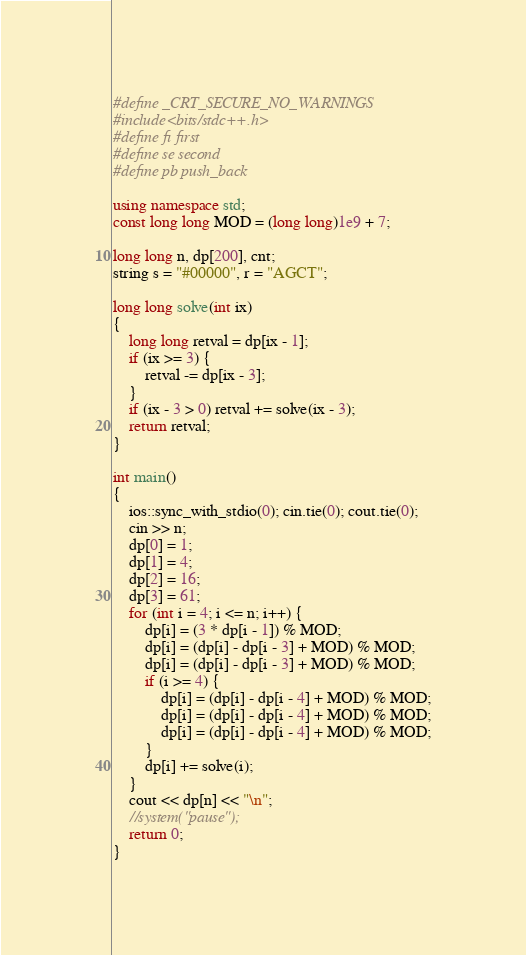Convert code to text. <code><loc_0><loc_0><loc_500><loc_500><_C++_>#define _CRT_SECURE_NO_WARNINGS
#include<bits/stdc++.h>
#define fi first
#define se second
#define pb push_back

using namespace std;
const long long MOD = (long long)1e9 + 7;

long long n, dp[200], cnt;
string s = "#00000", r = "AGCT";

long long solve(int ix)
{
	long long retval = dp[ix - 1];
	if (ix >= 3) {
		retval -= dp[ix - 3];
	}
	if (ix - 3 > 0) retval += solve(ix - 3);
	return retval;
}

int main()
{
	ios::sync_with_stdio(0); cin.tie(0); cout.tie(0);
	cin >> n;
	dp[0] = 1;
	dp[1] = 4;
	dp[2] = 16;
	dp[3] = 61;
	for (int i = 4; i <= n; i++) {
		dp[i] = (3 * dp[i - 1]) % MOD;
		dp[i] = (dp[i] - dp[i - 3] + MOD) % MOD;
		dp[i] = (dp[i] - dp[i - 3] + MOD) % MOD;
		if (i >= 4) {
			dp[i] = (dp[i] - dp[i - 4] + MOD) % MOD;
			dp[i] = (dp[i] - dp[i - 4] + MOD) % MOD;
			dp[i] = (dp[i] - dp[i - 4] + MOD) % MOD;
		}
		dp[i] += solve(i);
	}
	cout << dp[n] << "\n";
	//system("pause");
	return 0;
}
</code> 